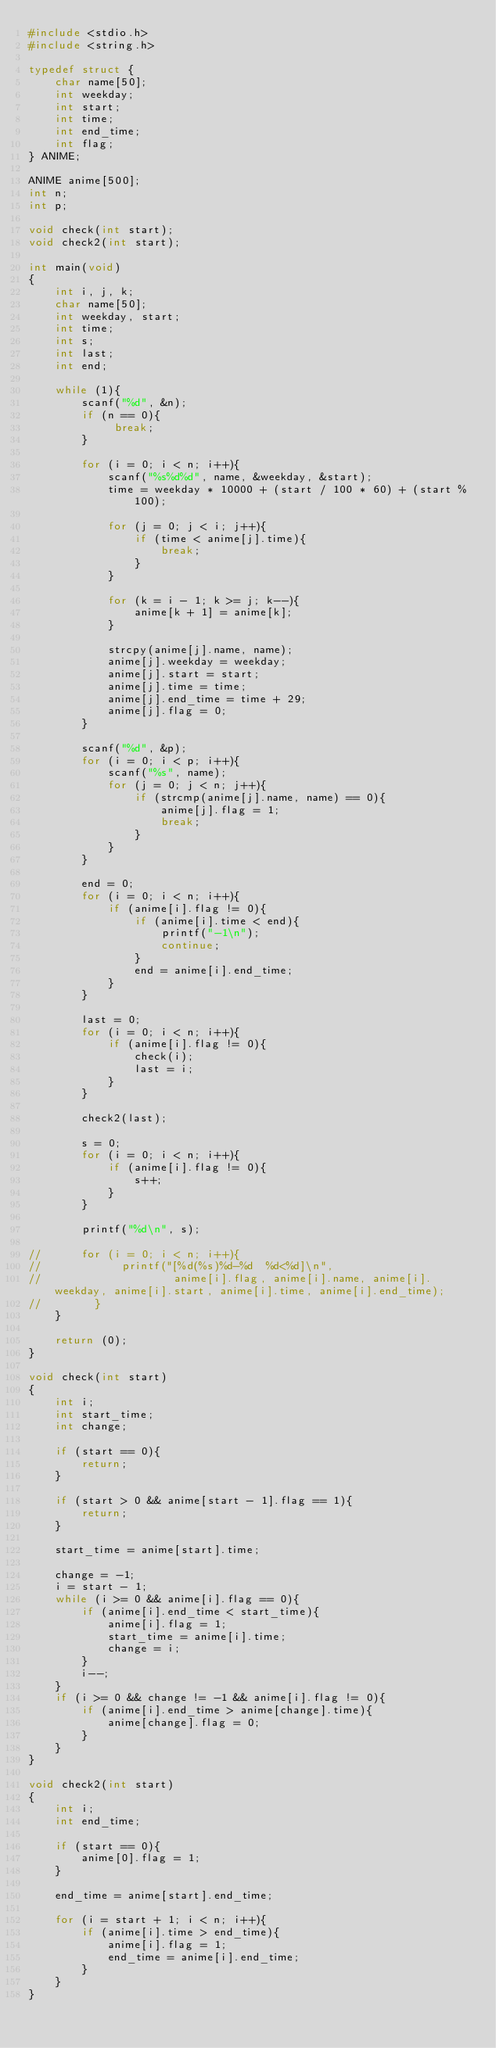<code> <loc_0><loc_0><loc_500><loc_500><_C_>#include <stdio.h>
#include <string.h>

typedef struct {
    char name[50];
    int weekday;
    int start;
    int time;
    int end_time;
    int flag;
} ANIME;

ANIME anime[500];
int n;
int p;

void check(int start);
void check2(int start);

int main(void)
{
    int i, j, k;
    char name[50];
    int weekday, start;
    int time;
    int s;
    int last;
    int end;
    
    while (1){
        scanf("%d", &n);
        if (n == 0){
             break;
        }
        
        for (i = 0; i < n; i++){
            scanf("%s%d%d", name, &weekday, &start);
            time = weekday * 10000 + (start / 100 * 60) + (start % 100);

            for (j = 0; j < i; j++){
                if (time < anime[j].time){
                    break;
                }
            }
            
            for (k = i - 1; k >= j; k--){
                anime[k + 1] = anime[k];
            }
            
            strcpy(anime[j].name, name);
            anime[j].weekday = weekday;
            anime[j].start = start;
            anime[j].time = time;
            anime[j].end_time = time + 29;
            anime[j].flag = 0;
        }

        scanf("%d", &p);
        for (i = 0; i < p; i++){
            scanf("%s", name);
            for (j = 0; j < n; j++){
                if (strcmp(anime[j].name, name) == 0){
                    anime[j].flag = 1;
                    break;
                }
            }
        }

        end = 0;
        for (i = 0; i < n; i++){
            if (anime[i].flag != 0){
                if (anime[i].time < end){
                    printf("-1\n");
                    continue;
                }
                end = anime[i].end_time;
            }
        }
        
        last = 0;
        for (i = 0; i < n; i++){
            if (anime[i].flag != 0){
                check(i);
                last = i;
            }
        }

        check2(last);

        s = 0;
        for (i = 0; i < n; i++){
            if (anime[i].flag != 0){
                s++;
            }
        }
      
        printf("%d\n", s);
        
//      for (i = 0; i < n; i++){
//            printf("[%d(%s)%d-%d  %d<%d]\n", 
//                    anime[i].flag, anime[i].name, anime[i].weekday, anime[i].start, anime[i].time, anime[i].end_time);
//        }
    }
    
    return (0);
}

void check(int start)
{
    int i;
    int start_time;
    int change;
    
    if (start == 0){
        return;
    }

    if (start > 0 && anime[start - 1].flag == 1){
        return;
    }
    
    start_time = anime[start].time;
    
    change = -1;
    i = start - 1;
    while (i >= 0 && anime[i].flag == 0){
        if (anime[i].end_time < start_time){
            anime[i].flag = 1;
            start_time = anime[i].time;
            change = i;
        }
        i--;
    }
    if (i >= 0 && change != -1 && anime[i].flag != 0){
        if (anime[i].end_time > anime[change].time){
            anime[change].flag = 0;
        }
    }
}

void check2(int start)
{
    int i;
    int end_time;
    
    if (start == 0){
        anime[0].flag = 1;
    }
    
    end_time = anime[start].end_time;
    
    for (i = start + 1; i < n; i++){
        if (anime[i].time > end_time){
            anime[i].flag = 1;
            end_time = anime[i].end_time;
        }
    }
}</code> 